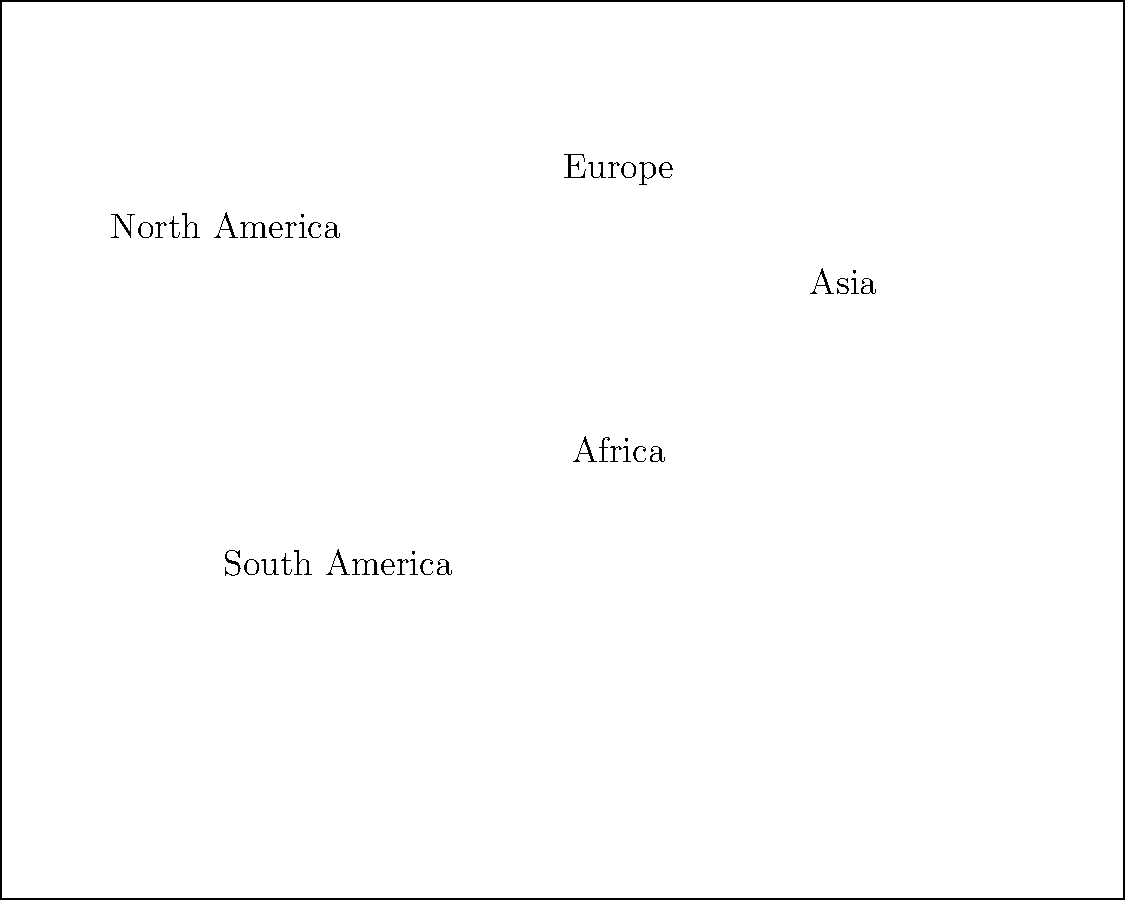Based on the world map and bar chart provided, which region has experienced the most significant negative impact on crop yields due to climate change, and what potential implications could this have for global food security? To answer this question, we need to analyze the information provided in the bar chart and consider its implications:

1. Examine the bar chart:
   - North America: +2.5% yield change
   - South America: -1.8% yield change
   - Europe: +0.7% yield change
   - Africa: -3.2% yield change
   - Asia: +1.5% yield change

2. Identify the region with the most significant negative impact:
   Africa has the largest negative yield change at -3.2%.

3. Consider the implications for global food security:
   a) Reduced food production in Africa could lead to increased food insecurity in the region.
   b) Africa is a major agricultural producer, so decreased yields could affect global food supply.
   c) Increased pressure on other regions to compensate for the production shortfall.
   d) Potential for increased food prices and reduced accessibility for vulnerable populations.
   e) Possible migration pressures as people seek better agricultural opportunities.

4. Analyze the broader context:
   - Some regions (North America, Europe, Asia) show positive yield changes, which could help offset losses elsewhere.
   - The overall global impact depends on the relative agricultural output of each region.

5. Consider adaptation and mitigation strategies:
   - Need for climate-resilient farming practices in affected regions.
   - Importance of international cooperation in addressing food security challenges.
   - Potential for technology transfer and agricultural innovation to improve yields in negatively impacted areas.
Answer: Africa, with -3.2% yield change, potentially leading to increased global food insecurity, higher prices, and regional instability. 